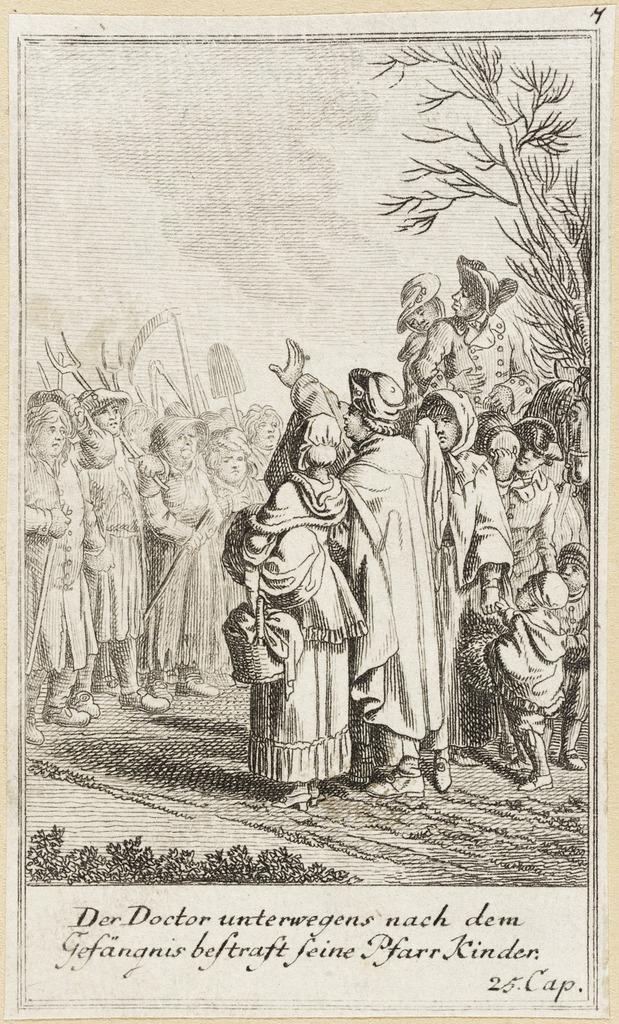How would you summarize this image in a sentence or two? In this picture there are few persons standing and holding an object in their hands and there is something written below the picture. 